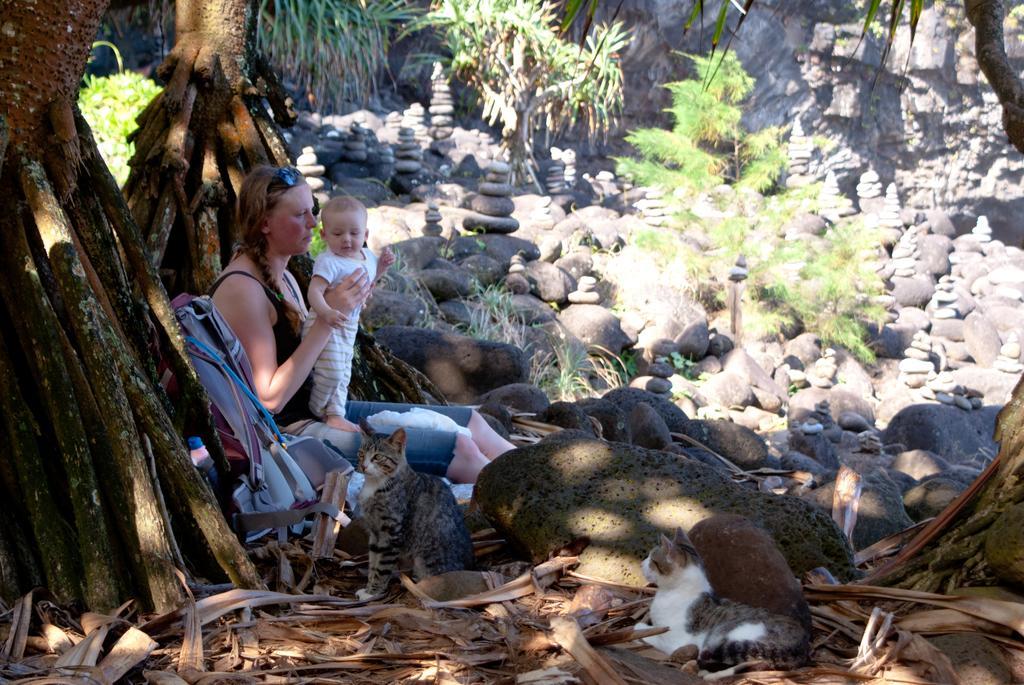Describe this image in one or two sentences. In this image I can see a woman holding a baby , sitting on chair ,beside the woman I can see two cats sitting on floor and I can see trunk of trees visible on the left side and in the middle I can see stones and plants. 